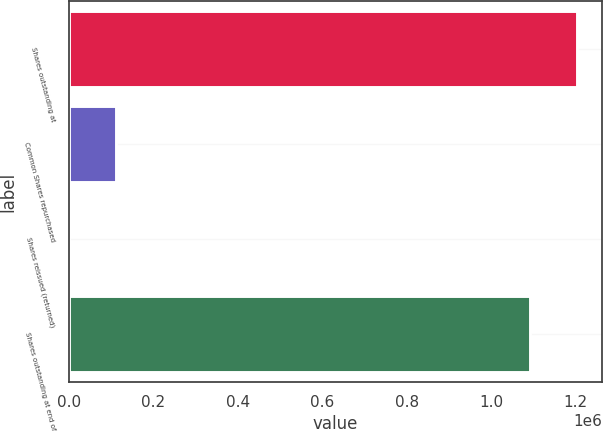Convert chart. <chart><loc_0><loc_0><loc_500><loc_500><bar_chart><fcel>Shares outstanding at<fcel>Common Shares repurchased<fcel>Shares reissued (returned)<fcel>Shares outstanding at end of<nl><fcel>1.20245e+06<fcel>110047<fcel>332<fcel>1.09274e+06<nl></chart> 